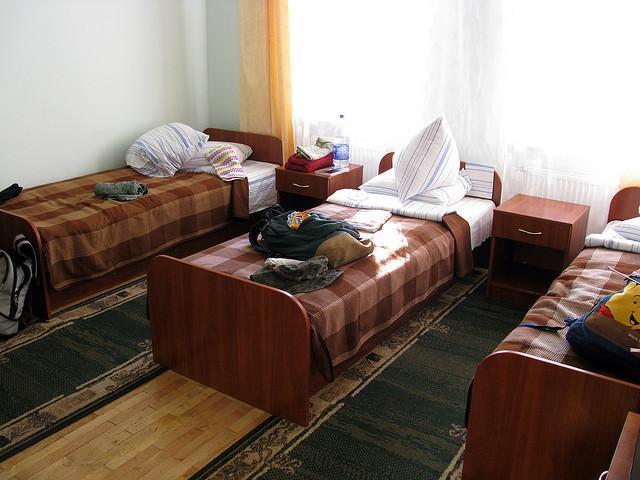How many beds?
Give a very brief answer. 3. How many rugs are shown?
Give a very brief answer. 2. How many beds can be seen?
Give a very brief answer. 3. How many backpacks are there?
Give a very brief answer. 3. 